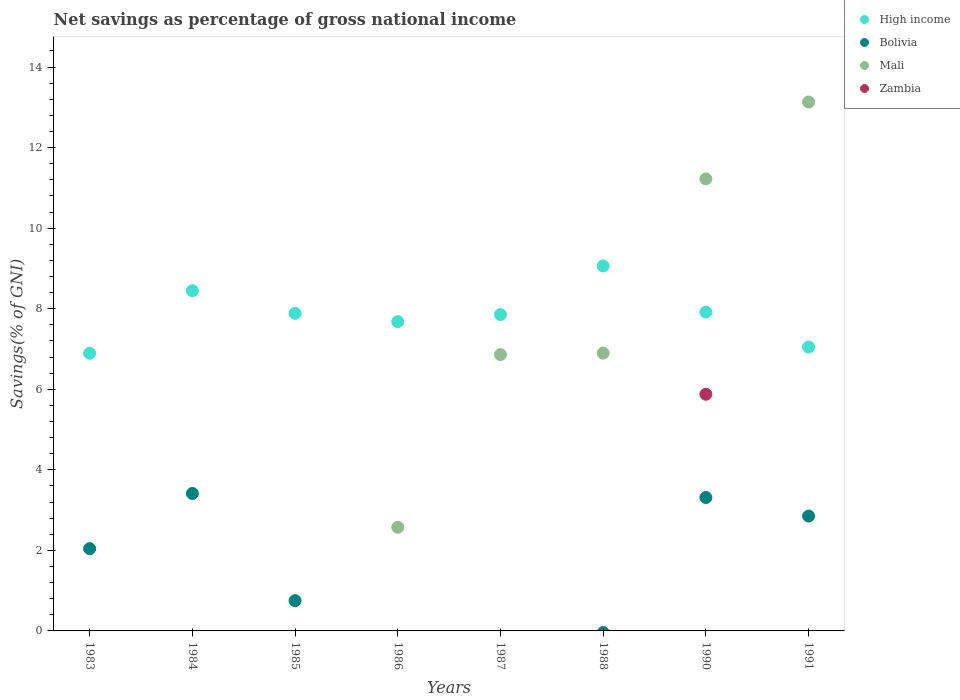Is the number of dotlines equal to the number of legend labels?
Ensure brevity in your answer.  No. What is the total savings in Mali in 1985?
Your answer should be very brief. 0. Across all years, what is the maximum total savings in High income?
Offer a very short reply. 9.06. Across all years, what is the minimum total savings in Bolivia?
Your answer should be very brief. 0. What is the total total savings in Bolivia in the graph?
Your response must be concise. 12.37. What is the difference between the total savings in High income in 1984 and that in 1986?
Your answer should be very brief. 0.77. What is the difference between the total savings in Mali in 1991 and the total savings in Bolivia in 1986?
Offer a very short reply. 13.13. What is the average total savings in Zambia per year?
Ensure brevity in your answer.  0.73. In the year 1991, what is the difference between the total savings in Mali and total savings in High income?
Offer a terse response. 6.08. What is the ratio of the total savings in Mali in 1987 to that in 1988?
Provide a short and direct response. 0.99. Is the total savings in High income in 1983 less than that in 1988?
Your answer should be compact. Yes. Is the difference between the total savings in Mali in 1990 and 1991 greater than the difference between the total savings in High income in 1990 and 1991?
Your response must be concise. No. What is the difference between the highest and the second highest total savings in Mali?
Your answer should be compact. 1.91. What is the difference between the highest and the lowest total savings in Zambia?
Your response must be concise. 5.88. Is it the case that in every year, the sum of the total savings in High income and total savings in Bolivia  is greater than the total savings in Zambia?
Keep it short and to the point. Yes. Does the total savings in High income monotonically increase over the years?
Ensure brevity in your answer.  No. Is the total savings in Bolivia strictly less than the total savings in High income over the years?
Keep it short and to the point. Yes. How many dotlines are there?
Provide a succinct answer. 4. How many years are there in the graph?
Offer a terse response. 8. Are the values on the major ticks of Y-axis written in scientific E-notation?
Provide a short and direct response. No. Does the graph contain any zero values?
Keep it short and to the point. Yes. Does the graph contain grids?
Offer a very short reply. No. Where does the legend appear in the graph?
Offer a very short reply. Top right. What is the title of the graph?
Provide a succinct answer. Net savings as percentage of gross national income. Does "Angola" appear as one of the legend labels in the graph?
Your answer should be very brief. No. What is the label or title of the X-axis?
Ensure brevity in your answer.  Years. What is the label or title of the Y-axis?
Your answer should be very brief. Savings(% of GNI). What is the Savings(% of GNI) of High income in 1983?
Provide a short and direct response. 6.89. What is the Savings(% of GNI) of Bolivia in 1983?
Offer a terse response. 2.04. What is the Savings(% of GNI) in High income in 1984?
Offer a terse response. 8.45. What is the Savings(% of GNI) of Bolivia in 1984?
Provide a succinct answer. 3.41. What is the Savings(% of GNI) in Mali in 1984?
Your answer should be very brief. 0. What is the Savings(% of GNI) in High income in 1985?
Provide a short and direct response. 7.89. What is the Savings(% of GNI) in Bolivia in 1985?
Give a very brief answer. 0.75. What is the Savings(% of GNI) in Zambia in 1985?
Your response must be concise. 0. What is the Savings(% of GNI) of High income in 1986?
Your answer should be very brief. 7.68. What is the Savings(% of GNI) in Bolivia in 1986?
Your response must be concise. 0. What is the Savings(% of GNI) of Mali in 1986?
Ensure brevity in your answer.  2.57. What is the Savings(% of GNI) in High income in 1987?
Ensure brevity in your answer.  7.85. What is the Savings(% of GNI) in Mali in 1987?
Provide a short and direct response. 6.86. What is the Savings(% of GNI) of Zambia in 1987?
Provide a short and direct response. 0. What is the Savings(% of GNI) in High income in 1988?
Your answer should be very brief. 9.06. What is the Savings(% of GNI) in Mali in 1988?
Your response must be concise. 6.9. What is the Savings(% of GNI) in High income in 1990?
Your answer should be very brief. 7.92. What is the Savings(% of GNI) of Bolivia in 1990?
Offer a terse response. 3.31. What is the Savings(% of GNI) of Mali in 1990?
Provide a short and direct response. 11.22. What is the Savings(% of GNI) of Zambia in 1990?
Provide a succinct answer. 5.88. What is the Savings(% of GNI) of High income in 1991?
Offer a very short reply. 7.05. What is the Savings(% of GNI) of Bolivia in 1991?
Offer a very short reply. 2.85. What is the Savings(% of GNI) of Mali in 1991?
Give a very brief answer. 13.13. Across all years, what is the maximum Savings(% of GNI) of High income?
Provide a short and direct response. 9.06. Across all years, what is the maximum Savings(% of GNI) in Bolivia?
Offer a terse response. 3.41. Across all years, what is the maximum Savings(% of GNI) of Mali?
Your response must be concise. 13.13. Across all years, what is the maximum Savings(% of GNI) in Zambia?
Ensure brevity in your answer.  5.88. Across all years, what is the minimum Savings(% of GNI) in High income?
Ensure brevity in your answer.  6.89. Across all years, what is the minimum Savings(% of GNI) in Mali?
Keep it short and to the point. 0. Across all years, what is the minimum Savings(% of GNI) of Zambia?
Make the answer very short. 0. What is the total Savings(% of GNI) of High income in the graph?
Your response must be concise. 62.78. What is the total Savings(% of GNI) in Bolivia in the graph?
Provide a succinct answer. 12.37. What is the total Savings(% of GNI) of Mali in the graph?
Ensure brevity in your answer.  40.68. What is the total Savings(% of GNI) in Zambia in the graph?
Your response must be concise. 5.88. What is the difference between the Savings(% of GNI) in High income in 1983 and that in 1984?
Your answer should be very brief. -1.55. What is the difference between the Savings(% of GNI) in Bolivia in 1983 and that in 1984?
Offer a very short reply. -1.37. What is the difference between the Savings(% of GNI) in High income in 1983 and that in 1985?
Provide a short and direct response. -0.99. What is the difference between the Savings(% of GNI) of Bolivia in 1983 and that in 1985?
Give a very brief answer. 1.29. What is the difference between the Savings(% of GNI) in High income in 1983 and that in 1986?
Give a very brief answer. -0.79. What is the difference between the Savings(% of GNI) in High income in 1983 and that in 1987?
Provide a succinct answer. -0.96. What is the difference between the Savings(% of GNI) of High income in 1983 and that in 1988?
Offer a very short reply. -2.17. What is the difference between the Savings(% of GNI) in High income in 1983 and that in 1990?
Give a very brief answer. -1.02. What is the difference between the Savings(% of GNI) in Bolivia in 1983 and that in 1990?
Ensure brevity in your answer.  -1.27. What is the difference between the Savings(% of GNI) of High income in 1983 and that in 1991?
Keep it short and to the point. -0.15. What is the difference between the Savings(% of GNI) in Bolivia in 1983 and that in 1991?
Your answer should be compact. -0.81. What is the difference between the Savings(% of GNI) of High income in 1984 and that in 1985?
Provide a short and direct response. 0.56. What is the difference between the Savings(% of GNI) of Bolivia in 1984 and that in 1985?
Provide a short and direct response. 2.66. What is the difference between the Savings(% of GNI) of High income in 1984 and that in 1986?
Make the answer very short. 0.77. What is the difference between the Savings(% of GNI) in High income in 1984 and that in 1987?
Your answer should be compact. 0.59. What is the difference between the Savings(% of GNI) of High income in 1984 and that in 1988?
Your response must be concise. -0.61. What is the difference between the Savings(% of GNI) in High income in 1984 and that in 1990?
Offer a very short reply. 0.53. What is the difference between the Savings(% of GNI) in Bolivia in 1984 and that in 1990?
Your response must be concise. 0.1. What is the difference between the Savings(% of GNI) of High income in 1984 and that in 1991?
Your answer should be compact. 1.4. What is the difference between the Savings(% of GNI) of Bolivia in 1984 and that in 1991?
Your response must be concise. 0.56. What is the difference between the Savings(% of GNI) of High income in 1985 and that in 1986?
Make the answer very short. 0.21. What is the difference between the Savings(% of GNI) of High income in 1985 and that in 1987?
Make the answer very short. 0.03. What is the difference between the Savings(% of GNI) in High income in 1985 and that in 1988?
Your answer should be very brief. -1.18. What is the difference between the Savings(% of GNI) of High income in 1985 and that in 1990?
Provide a short and direct response. -0.03. What is the difference between the Savings(% of GNI) of Bolivia in 1985 and that in 1990?
Your answer should be very brief. -2.56. What is the difference between the Savings(% of GNI) of High income in 1985 and that in 1991?
Your response must be concise. 0.84. What is the difference between the Savings(% of GNI) of Bolivia in 1985 and that in 1991?
Your answer should be very brief. -2.1. What is the difference between the Savings(% of GNI) of High income in 1986 and that in 1987?
Offer a terse response. -0.17. What is the difference between the Savings(% of GNI) of Mali in 1986 and that in 1987?
Offer a very short reply. -4.29. What is the difference between the Savings(% of GNI) in High income in 1986 and that in 1988?
Keep it short and to the point. -1.38. What is the difference between the Savings(% of GNI) in Mali in 1986 and that in 1988?
Keep it short and to the point. -4.32. What is the difference between the Savings(% of GNI) in High income in 1986 and that in 1990?
Offer a terse response. -0.24. What is the difference between the Savings(% of GNI) of Mali in 1986 and that in 1990?
Your response must be concise. -8.65. What is the difference between the Savings(% of GNI) in High income in 1986 and that in 1991?
Your response must be concise. 0.63. What is the difference between the Savings(% of GNI) in Mali in 1986 and that in 1991?
Provide a succinct answer. -10.56. What is the difference between the Savings(% of GNI) in High income in 1987 and that in 1988?
Offer a terse response. -1.21. What is the difference between the Savings(% of GNI) in Mali in 1987 and that in 1988?
Offer a very short reply. -0.04. What is the difference between the Savings(% of GNI) of High income in 1987 and that in 1990?
Offer a very short reply. -0.06. What is the difference between the Savings(% of GNI) in Mali in 1987 and that in 1990?
Give a very brief answer. -4.36. What is the difference between the Savings(% of GNI) in High income in 1987 and that in 1991?
Provide a succinct answer. 0.81. What is the difference between the Savings(% of GNI) of Mali in 1987 and that in 1991?
Your answer should be compact. -6.27. What is the difference between the Savings(% of GNI) in High income in 1988 and that in 1990?
Your response must be concise. 1.15. What is the difference between the Savings(% of GNI) of Mali in 1988 and that in 1990?
Your answer should be compact. -4.33. What is the difference between the Savings(% of GNI) of High income in 1988 and that in 1991?
Offer a very short reply. 2.01. What is the difference between the Savings(% of GNI) of Mali in 1988 and that in 1991?
Provide a short and direct response. -6.24. What is the difference between the Savings(% of GNI) in High income in 1990 and that in 1991?
Keep it short and to the point. 0.87. What is the difference between the Savings(% of GNI) in Bolivia in 1990 and that in 1991?
Offer a very short reply. 0.46. What is the difference between the Savings(% of GNI) of Mali in 1990 and that in 1991?
Provide a succinct answer. -1.91. What is the difference between the Savings(% of GNI) of High income in 1983 and the Savings(% of GNI) of Bolivia in 1984?
Offer a terse response. 3.48. What is the difference between the Savings(% of GNI) of High income in 1983 and the Savings(% of GNI) of Bolivia in 1985?
Provide a succinct answer. 6.14. What is the difference between the Savings(% of GNI) of High income in 1983 and the Savings(% of GNI) of Mali in 1986?
Offer a terse response. 4.32. What is the difference between the Savings(% of GNI) in Bolivia in 1983 and the Savings(% of GNI) in Mali in 1986?
Offer a very short reply. -0.53. What is the difference between the Savings(% of GNI) in High income in 1983 and the Savings(% of GNI) in Mali in 1987?
Keep it short and to the point. 0.03. What is the difference between the Savings(% of GNI) of Bolivia in 1983 and the Savings(% of GNI) of Mali in 1987?
Your answer should be compact. -4.82. What is the difference between the Savings(% of GNI) in High income in 1983 and the Savings(% of GNI) in Mali in 1988?
Give a very brief answer. -0. What is the difference between the Savings(% of GNI) of Bolivia in 1983 and the Savings(% of GNI) of Mali in 1988?
Your response must be concise. -4.85. What is the difference between the Savings(% of GNI) of High income in 1983 and the Savings(% of GNI) of Bolivia in 1990?
Provide a succinct answer. 3.58. What is the difference between the Savings(% of GNI) in High income in 1983 and the Savings(% of GNI) in Mali in 1990?
Provide a short and direct response. -4.33. What is the difference between the Savings(% of GNI) of High income in 1983 and the Savings(% of GNI) of Zambia in 1990?
Provide a short and direct response. 1.02. What is the difference between the Savings(% of GNI) of Bolivia in 1983 and the Savings(% of GNI) of Mali in 1990?
Your answer should be very brief. -9.18. What is the difference between the Savings(% of GNI) of Bolivia in 1983 and the Savings(% of GNI) of Zambia in 1990?
Your answer should be very brief. -3.83. What is the difference between the Savings(% of GNI) in High income in 1983 and the Savings(% of GNI) in Bolivia in 1991?
Keep it short and to the point. 4.04. What is the difference between the Savings(% of GNI) of High income in 1983 and the Savings(% of GNI) of Mali in 1991?
Offer a terse response. -6.24. What is the difference between the Savings(% of GNI) of Bolivia in 1983 and the Savings(% of GNI) of Mali in 1991?
Offer a very short reply. -11.09. What is the difference between the Savings(% of GNI) in High income in 1984 and the Savings(% of GNI) in Bolivia in 1985?
Provide a succinct answer. 7.7. What is the difference between the Savings(% of GNI) of High income in 1984 and the Savings(% of GNI) of Mali in 1986?
Ensure brevity in your answer.  5.87. What is the difference between the Savings(% of GNI) in Bolivia in 1984 and the Savings(% of GNI) in Mali in 1986?
Make the answer very short. 0.84. What is the difference between the Savings(% of GNI) of High income in 1984 and the Savings(% of GNI) of Mali in 1987?
Provide a short and direct response. 1.59. What is the difference between the Savings(% of GNI) of Bolivia in 1984 and the Savings(% of GNI) of Mali in 1987?
Your answer should be compact. -3.45. What is the difference between the Savings(% of GNI) in High income in 1984 and the Savings(% of GNI) in Mali in 1988?
Make the answer very short. 1.55. What is the difference between the Savings(% of GNI) of Bolivia in 1984 and the Savings(% of GNI) of Mali in 1988?
Give a very brief answer. -3.48. What is the difference between the Savings(% of GNI) in High income in 1984 and the Savings(% of GNI) in Bolivia in 1990?
Keep it short and to the point. 5.14. What is the difference between the Savings(% of GNI) in High income in 1984 and the Savings(% of GNI) in Mali in 1990?
Provide a short and direct response. -2.77. What is the difference between the Savings(% of GNI) of High income in 1984 and the Savings(% of GNI) of Zambia in 1990?
Give a very brief answer. 2.57. What is the difference between the Savings(% of GNI) in Bolivia in 1984 and the Savings(% of GNI) in Mali in 1990?
Offer a very short reply. -7.81. What is the difference between the Savings(% of GNI) of Bolivia in 1984 and the Savings(% of GNI) of Zambia in 1990?
Your answer should be compact. -2.46. What is the difference between the Savings(% of GNI) in High income in 1984 and the Savings(% of GNI) in Bolivia in 1991?
Your answer should be compact. 5.6. What is the difference between the Savings(% of GNI) in High income in 1984 and the Savings(% of GNI) in Mali in 1991?
Ensure brevity in your answer.  -4.68. What is the difference between the Savings(% of GNI) of Bolivia in 1984 and the Savings(% of GNI) of Mali in 1991?
Give a very brief answer. -9.72. What is the difference between the Savings(% of GNI) of High income in 1985 and the Savings(% of GNI) of Mali in 1986?
Offer a terse response. 5.31. What is the difference between the Savings(% of GNI) in Bolivia in 1985 and the Savings(% of GNI) in Mali in 1986?
Ensure brevity in your answer.  -1.82. What is the difference between the Savings(% of GNI) in High income in 1985 and the Savings(% of GNI) in Mali in 1987?
Offer a very short reply. 1.02. What is the difference between the Savings(% of GNI) of Bolivia in 1985 and the Savings(% of GNI) of Mali in 1987?
Give a very brief answer. -6.11. What is the difference between the Savings(% of GNI) in Bolivia in 1985 and the Savings(% of GNI) in Mali in 1988?
Offer a very short reply. -6.14. What is the difference between the Savings(% of GNI) of High income in 1985 and the Savings(% of GNI) of Bolivia in 1990?
Ensure brevity in your answer.  4.57. What is the difference between the Savings(% of GNI) of High income in 1985 and the Savings(% of GNI) of Mali in 1990?
Your response must be concise. -3.34. What is the difference between the Savings(% of GNI) of High income in 1985 and the Savings(% of GNI) of Zambia in 1990?
Offer a terse response. 2.01. What is the difference between the Savings(% of GNI) in Bolivia in 1985 and the Savings(% of GNI) in Mali in 1990?
Provide a short and direct response. -10.47. What is the difference between the Savings(% of GNI) of Bolivia in 1985 and the Savings(% of GNI) of Zambia in 1990?
Ensure brevity in your answer.  -5.12. What is the difference between the Savings(% of GNI) of High income in 1985 and the Savings(% of GNI) of Bolivia in 1991?
Give a very brief answer. 5.03. What is the difference between the Savings(% of GNI) of High income in 1985 and the Savings(% of GNI) of Mali in 1991?
Offer a very short reply. -5.25. What is the difference between the Savings(% of GNI) in Bolivia in 1985 and the Savings(% of GNI) in Mali in 1991?
Keep it short and to the point. -12.38. What is the difference between the Savings(% of GNI) in High income in 1986 and the Savings(% of GNI) in Mali in 1987?
Offer a very short reply. 0.82. What is the difference between the Savings(% of GNI) of High income in 1986 and the Savings(% of GNI) of Mali in 1988?
Make the answer very short. 0.78. What is the difference between the Savings(% of GNI) in High income in 1986 and the Savings(% of GNI) in Bolivia in 1990?
Give a very brief answer. 4.37. What is the difference between the Savings(% of GNI) of High income in 1986 and the Savings(% of GNI) of Mali in 1990?
Provide a succinct answer. -3.54. What is the difference between the Savings(% of GNI) in High income in 1986 and the Savings(% of GNI) in Zambia in 1990?
Provide a succinct answer. 1.8. What is the difference between the Savings(% of GNI) of Mali in 1986 and the Savings(% of GNI) of Zambia in 1990?
Keep it short and to the point. -3.3. What is the difference between the Savings(% of GNI) in High income in 1986 and the Savings(% of GNI) in Bolivia in 1991?
Offer a very short reply. 4.83. What is the difference between the Savings(% of GNI) of High income in 1986 and the Savings(% of GNI) of Mali in 1991?
Offer a terse response. -5.45. What is the difference between the Savings(% of GNI) in High income in 1987 and the Savings(% of GNI) in Bolivia in 1990?
Give a very brief answer. 4.54. What is the difference between the Savings(% of GNI) of High income in 1987 and the Savings(% of GNI) of Mali in 1990?
Offer a very short reply. -3.37. What is the difference between the Savings(% of GNI) of High income in 1987 and the Savings(% of GNI) of Zambia in 1990?
Offer a very short reply. 1.98. What is the difference between the Savings(% of GNI) in Mali in 1987 and the Savings(% of GNI) in Zambia in 1990?
Make the answer very short. 0.98. What is the difference between the Savings(% of GNI) in High income in 1987 and the Savings(% of GNI) in Bolivia in 1991?
Your response must be concise. 5. What is the difference between the Savings(% of GNI) in High income in 1987 and the Savings(% of GNI) in Mali in 1991?
Make the answer very short. -5.28. What is the difference between the Savings(% of GNI) of High income in 1988 and the Savings(% of GNI) of Bolivia in 1990?
Give a very brief answer. 5.75. What is the difference between the Savings(% of GNI) of High income in 1988 and the Savings(% of GNI) of Mali in 1990?
Offer a terse response. -2.16. What is the difference between the Savings(% of GNI) of High income in 1988 and the Savings(% of GNI) of Zambia in 1990?
Provide a succinct answer. 3.19. What is the difference between the Savings(% of GNI) in Mali in 1988 and the Savings(% of GNI) in Zambia in 1990?
Give a very brief answer. 1.02. What is the difference between the Savings(% of GNI) in High income in 1988 and the Savings(% of GNI) in Bolivia in 1991?
Make the answer very short. 6.21. What is the difference between the Savings(% of GNI) of High income in 1988 and the Savings(% of GNI) of Mali in 1991?
Provide a short and direct response. -4.07. What is the difference between the Savings(% of GNI) in High income in 1990 and the Savings(% of GNI) in Bolivia in 1991?
Ensure brevity in your answer.  5.06. What is the difference between the Savings(% of GNI) in High income in 1990 and the Savings(% of GNI) in Mali in 1991?
Offer a very short reply. -5.22. What is the difference between the Savings(% of GNI) of Bolivia in 1990 and the Savings(% of GNI) of Mali in 1991?
Ensure brevity in your answer.  -9.82. What is the average Savings(% of GNI) in High income per year?
Keep it short and to the point. 7.85. What is the average Savings(% of GNI) in Bolivia per year?
Keep it short and to the point. 1.55. What is the average Savings(% of GNI) of Mali per year?
Your answer should be compact. 5.09. What is the average Savings(% of GNI) in Zambia per year?
Keep it short and to the point. 0.73. In the year 1983, what is the difference between the Savings(% of GNI) of High income and Savings(% of GNI) of Bolivia?
Give a very brief answer. 4.85. In the year 1984, what is the difference between the Savings(% of GNI) in High income and Savings(% of GNI) in Bolivia?
Provide a succinct answer. 5.04. In the year 1985, what is the difference between the Savings(% of GNI) of High income and Savings(% of GNI) of Bolivia?
Your response must be concise. 7.13. In the year 1986, what is the difference between the Savings(% of GNI) in High income and Savings(% of GNI) in Mali?
Offer a very short reply. 5.11. In the year 1988, what is the difference between the Savings(% of GNI) in High income and Savings(% of GNI) in Mali?
Offer a very short reply. 2.17. In the year 1990, what is the difference between the Savings(% of GNI) of High income and Savings(% of GNI) of Bolivia?
Make the answer very short. 4.6. In the year 1990, what is the difference between the Savings(% of GNI) in High income and Savings(% of GNI) in Mali?
Provide a short and direct response. -3.31. In the year 1990, what is the difference between the Savings(% of GNI) in High income and Savings(% of GNI) in Zambia?
Your response must be concise. 2.04. In the year 1990, what is the difference between the Savings(% of GNI) in Bolivia and Savings(% of GNI) in Mali?
Make the answer very short. -7.91. In the year 1990, what is the difference between the Savings(% of GNI) of Bolivia and Savings(% of GNI) of Zambia?
Make the answer very short. -2.56. In the year 1990, what is the difference between the Savings(% of GNI) of Mali and Savings(% of GNI) of Zambia?
Your answer should be very brief. 5.35. In the year 1991, what is the difference between the Savings(% of GNI) of High income and Savings(% of GNI) of Bolivia?
Offer a terse response. 4.2. In the year 1991, what is the difference between the Savings(% of GNI) in High income and Savings(% of GNI) in Mali?
Your answer should be compact. -6.08. In the year 1991, what is the difference between the Savings(% of GNI) of Bolivia and Savings(% of GNI) of Mali?
Offer a very short reply. -10.28. What is the ratio of the Savings(% of GNI) in High income in 1983 to that in 1984?
Your answer should be very brief. 0.82. What is the ratio of the Savings(% of GNI) in Bolivia in 1983 to that in 1984?
Offer a very short reply. 0.6. What is the ratio of the Savings(% of GNI) of High income in 1983 to that in 1985?
Provide a succinct answer. 0.87. What is the ratio of the Savings(% of GNI) of Bolivia in 1983 to that in 1985?
Your answer should be very brief. 2.72. What is the ratio of the Savings(% of GNI) in High income in 1983 to that in 1986?
Provide a succinct answer. 0.9. What is the ratio of the Savings(% of GNI) of High income in 1983 to that in 1987?
Your answer should be compact. 0.88. What is the ratio of the Savings(% of GNI) in High income in 1983 to that in 1988?
Ensure brevity in your answer.  0.76. What is the ratio of the Savings(% of GNI) of High income in 1983 to that in 1990?
Keep it short and to the point. 0.87. What is the ratio of the Savings(% of GNI) of Bolivia in 1983 to that in 1990?
Keep it short and to the point. 0.62. What is the ratio of the Savings(% of GNI) of Bolivia in 1983 to that in 1991?
Give a very brief answer. 0.72. What is the ratio of the Savings(% of GNI) of High income in 1984 to that in 1985?
Your answer should be very brief. 1.07. What is the ratio of the Savings(% of GNI) of Bolivia in 1984 to that in 1985?
Provide a short and direct response. 4.54. What is the ratio of the Savings(% of GNI) in High income in 1984 to that in 1986?
Ensure brevity in your answer.  1.1. What is the ratio of the Savings(% of GNI) of High income in 1984 to that in 1987?
Keep it short and to the point. 1.08. What is the ratio of the Savings(% of GNI) in High income in 1984 to that in 1988?
Your answer should be very brief. 0.93. What is the ratio of the Savings(% of GNI) of High income in 1984 to that in 1990?
Your response must be concise. 1.07. What is the ratio of the Savings(% of GNI) in Bolivia in 1984 to that in 1990?
Offer a terse response. 1.03. What is the ratio of the Savings(% of GNI) of High income in 1984 to that in 1991?
Offer a terse response. 1.2. What is the ratio of the Savings(% of GNI) of Bolivia in 1984 to that in 1991?
Your response must be concise. 1.2. What is the ratio of the Savings(% of GNI) in High income in 1985 to that in 1986?
Your answer should be very brief. 1.03. What is the ratio of the Savings(% of GNI) in High income in 1985 to that in 1988?
Provide a succinct answer. 0.87. What is the ratio of the Savings(% of GNI) of Bolivia in 1985 to that in 1990?
Keep it short and to the point. 0.23. What is the ratio of the Savings(% of GNI) of High income in 1985 to that in 1991?
Make the answer very short. 1.12. What is the ratio of the Savings(% of GNI) of Bolivia in 1985 to that in 1991?
Offer a very short reply. 0.26. What is the ratio of the Savings(% of GNI) of High income in 1986 to that in 1987?
Provide a succinct answer. 0.98. What is the ratio of the Savings(% of GNI) of Mali in 1986 to that in 1987?
Provide a succinct answer. 0.38. What is the ratio of the Savings(% of GNI) of High income in 1986 to that in 1988?
Keep it short and to the point. 0.85. What is the ratio of the Savings(% of GNI) of Mali in 1986 to that in 1988?
Provide a short and direct response. 0.37. What is the ratio of the Savings(% of GNI) in High income in 1986 to that in 1990?
Your answer should be very brief. 0.97. What is the ratio of the Savings(% of GNI) of Mali in 1986 to that in 1990?
Ensure brevity in your answer.  0.23. What is the ratio of the Savings(% of GNI) of High income in 1986 to that in 1991?
Provide a short and direct response. 1.09. What is the ratio of the Savings(% of GNI) of Mali in 1986 to that in 1991?
Your answer should be very brief. 0.2. What is the ratio of the Savings(% of GNI) in High income in 1987 to that in 1988?
Give a very brief answer. 0.87. What is the ratio of the Savings(% of GNI) of Mali in 1987 to that in 1988?
Ensure brevity in your answer.  0.99. What is the ratio of the Savings(% of GNI) of High income in 1987 to that in 1990?
Your response must be concise. 0.99. What is the ratio of the Savings(% of GNI) of Mali in 1987 to that in 1990?
Provide a short and direct response. 0.61. What is the ratio of the Savings(% of GNI) in High income in 1987 to that in 1991?
Give a very brief answer. 1.11. What is the ratio of the Savings(% of GNI) of Mali in 1987 to that in 1991?
Ensure brevity in your answer.  0.52. What is the ratio of the Savings(% of GNI) of High income in 1988 to that in 1990?
Ensure brevity in your answer.  1.14. What is the ratio of the Savings(% of GNI) in Mali in 1988 to that in 1990?
Ensure brevity in your answer.  0.61. What is the ratio of the Savings(% of GNI) in High income in 1988 to that in 1991?
Your answer should be very brief. 1.29. What is the ratio of the Savings(% of GNI) of Mali in 1988 to that in 1991?
Provide a succinct answer. 0.53. What is the ratio of the Savings(% of GNI) of High income in 1990 to that in 1991?
Ensure brevity in your answer.  1.12. What is the ratio of the Savings(% of GNI) in Bolivia in 1990 to that in 1991?
Provide a short and direct response. 1.16. What is the ratio of the Savings(% of GNI) of Mali in 1990 to that in 1991?
Give a very brief answer. 0.85. What is the difference between the highest and the second highest Savings(% of GNI) in High income?
Ensure brevity in your answer.  0.61. What is the difference between the highest and the second highest Savings(% of GNI) of Bolivia?
Your answer should be compact. 0.1. What is the difference between the highest and the second highest Savings(% of GNI) of Mali?
Offer a terse response. 1.91. What is the difference between the highest and the lowest Savings(% of GNI) in High income?
Make the answer very short. 2.17. What is the difference between the highest and the lowest Savings(% of GNI) in Bolivia?
Give a very brief answer. 3.41. What is the difference between the highest and the lowest Savings(% of GNI) in Mali?
Provide a short and direct response. 13.13. What is the difference between the highest and the lowest Savings(% of GNI) of Zambia?
Keep it short and to the point. 5.88. 